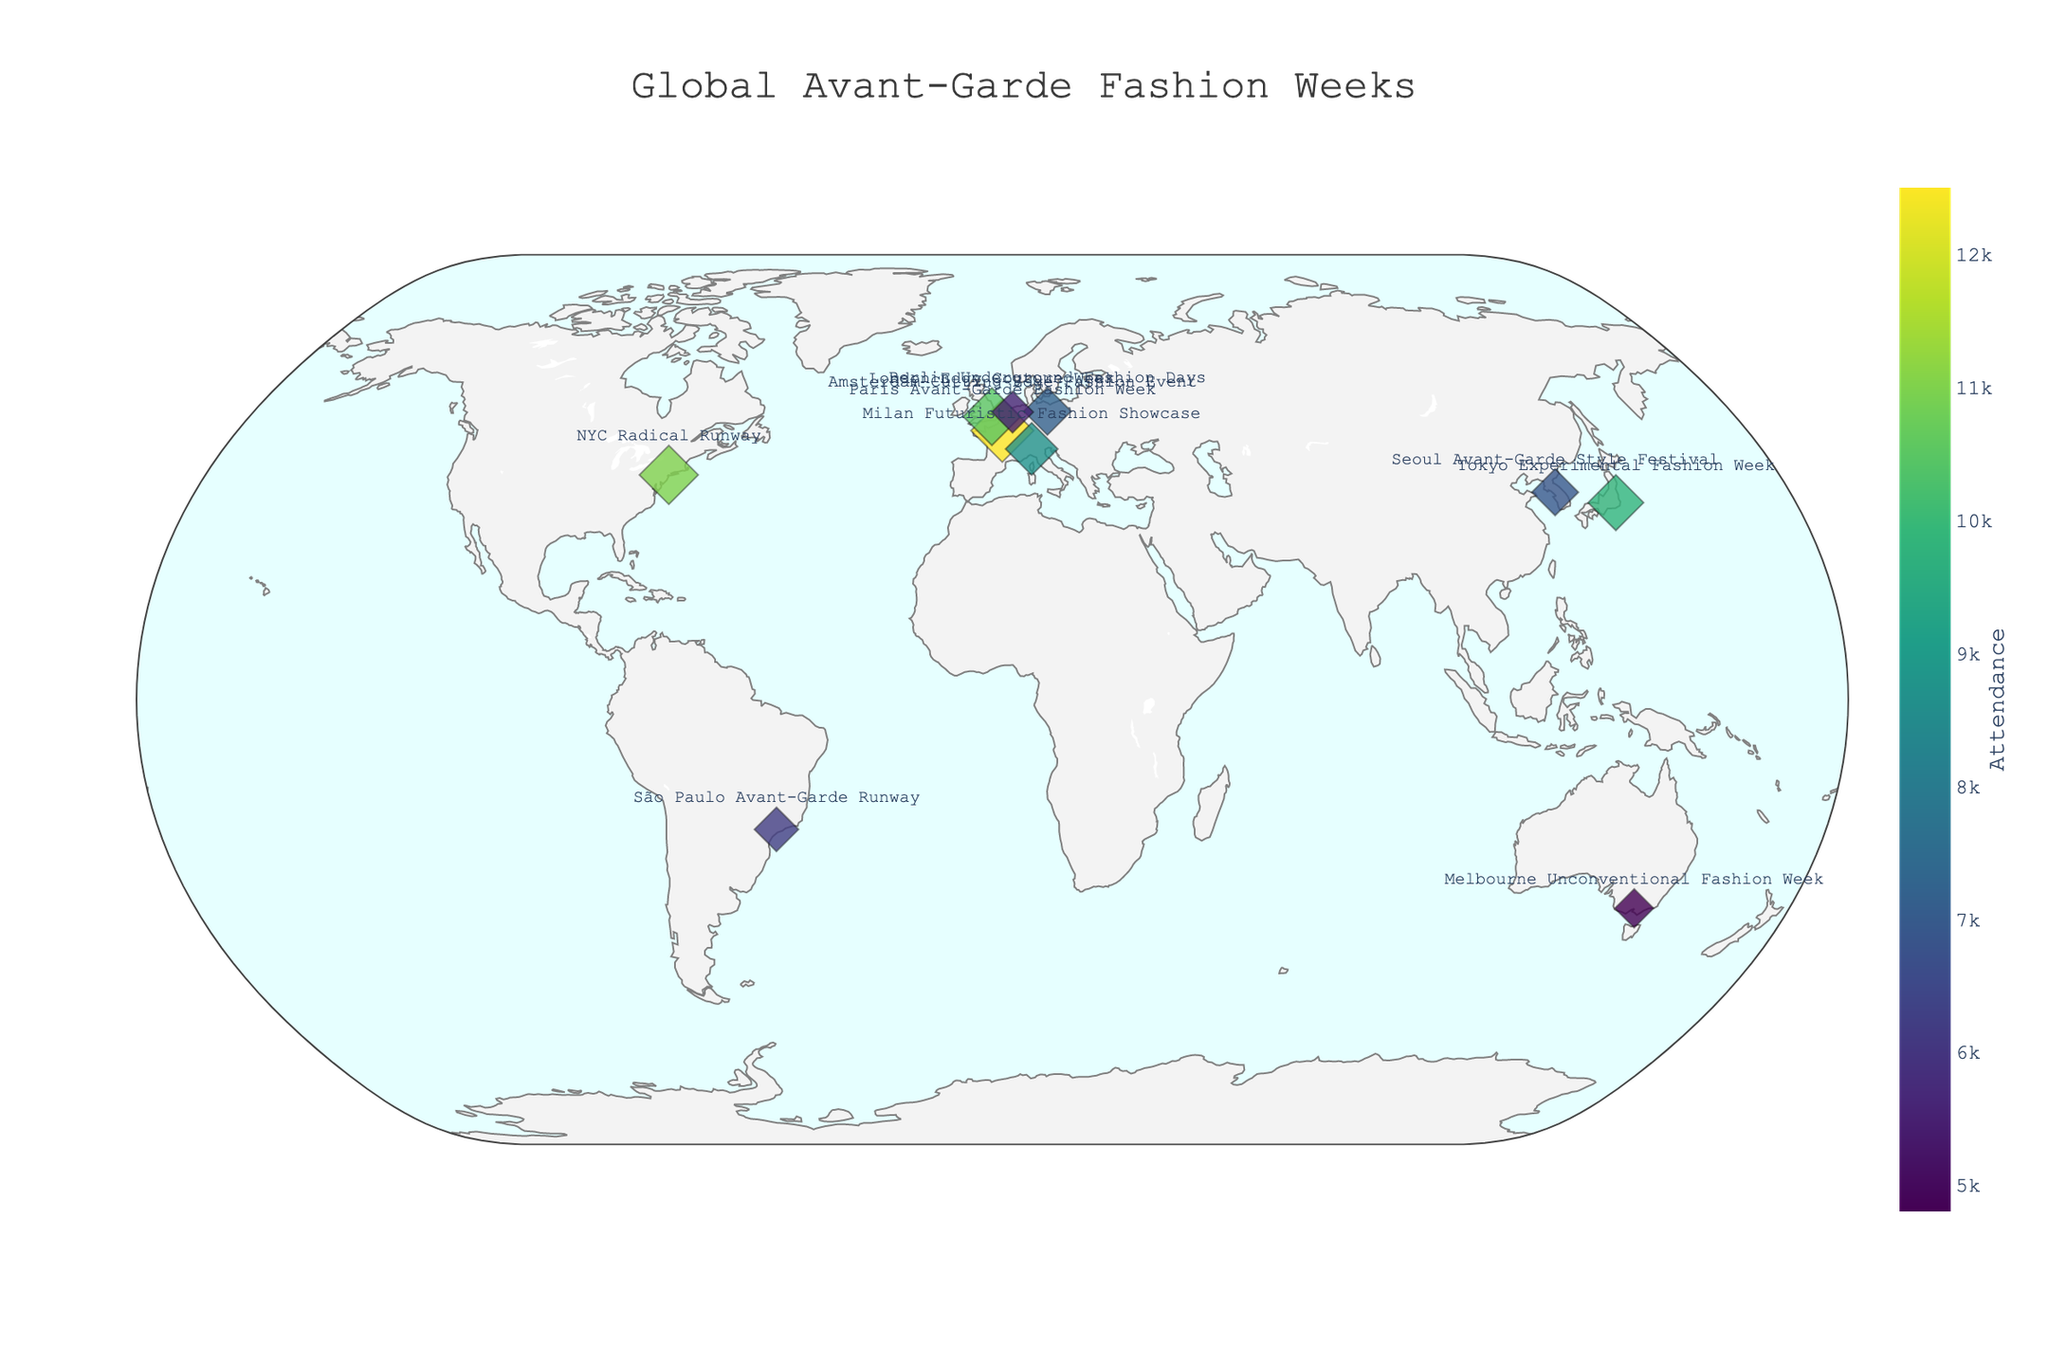How many cities are represented on this map? There are markers for each city on the map. By counting them, we get the total number of cities
Answer: 10 Which city has the highest attendance for their fashion week? Look for the largest marker on the map and check its hover information. The largest marker corresponds to Paris, France.
Answer: Paris Which city holds the "Milan Futuristic Fashion Showcase" and what is its attendance figure? Locate the marker label "Milan Futuristic Fashion Showcase" and check the hover information for attendance.
Answer: Milan, 8700 Which two cities have the closest attendance figures for their fashion weeks, and what are those figures? Compare the attendance figures for each city and find the two that are numerically closest. London (10500) and New York (11000) are closest.
Answer: London (10500) and New York (11000) What is the total attendance across all avant-garde fashion weeks shown on the map? Sum the attendance figures for all the cities (12500 + 9800 + 7200 + 11000 + 10500 + 8700 + 6900 + 5500 + 4800 + 6200) = 86700
Answer: 86700 Which city has the lowest attendance and what is its exact position on the map? Identify the smallest marker and check its hover information. Melbourne has the lowest attendance, located at Latitude -37.8136, Longitude 144.9631
Answer: Melbourne, -37.8136, 144.9631 How does the attendance of Tokyo Experimental Fashion Week compare to that of Seoul Avant-Garde Style Festival? Compare the attendance figures for Tokyo (9800) and Seoul (6900). Tokyo has a higher attendance.
Answer: Tokyo is higher What's the average attendance of all the avant-garde fashion weeks? Calculate the mean by dividing the total attendance (86700) by the number of cities (10). Average attendance = 86700 / 10 = 8670
Answer: 8670 Which city's event name is "Berlin Underground Fashion Days"? Find the marker labeled "Berlin Underground Fashion Days" and refer to the hover information for the city name.
Answer: Berlin What is the attendance difference between the city with the highest attendance and the city with the lowest attendance? Subtract the lowest attendance figure (4800) from the highest attendance figure (12500). Difference = 12500 - 4800 = 7700
Answer: 7700 